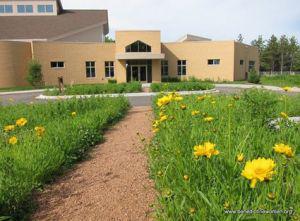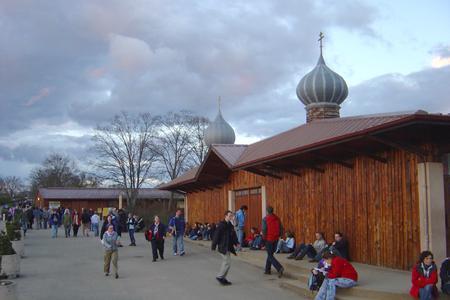The first image is the image on the left, the second image is the image on the right. Assess this claim about the two images: "One building is beige stone with arch elements and a landscaped lawn that includes shrubs.". Correct or not? Answer yes or no. No. The first image is the image on the left, the second image is the image on the right. Analyze the images presented: Is the assertion "There's a dirt path through the grass in the left image." valid? Answer yes or no. Yes. 